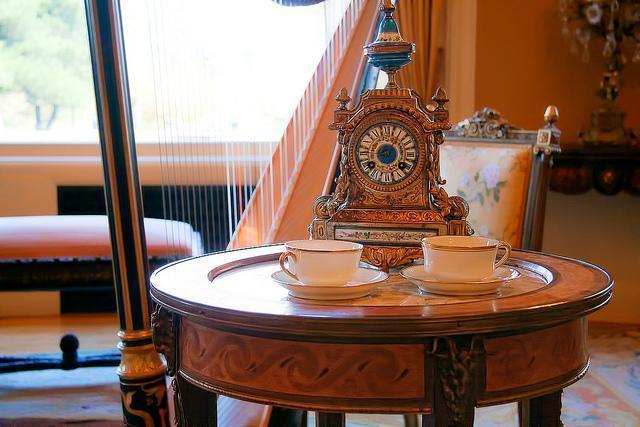How many cups can be seen?
Give a very brief answer. 2. 